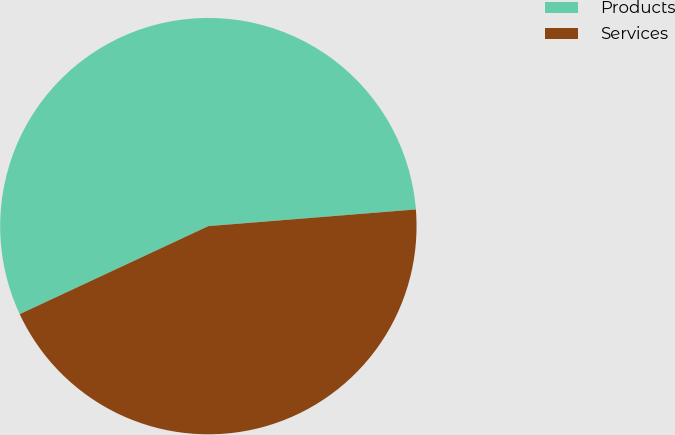Convert chart. <chart><loc_0><loc_0><loc_500><loc_500><pie_chart><fcel>Products<fcel>Services<nl><fcel>55.67%<fcel>44.33%<nl></chart> 